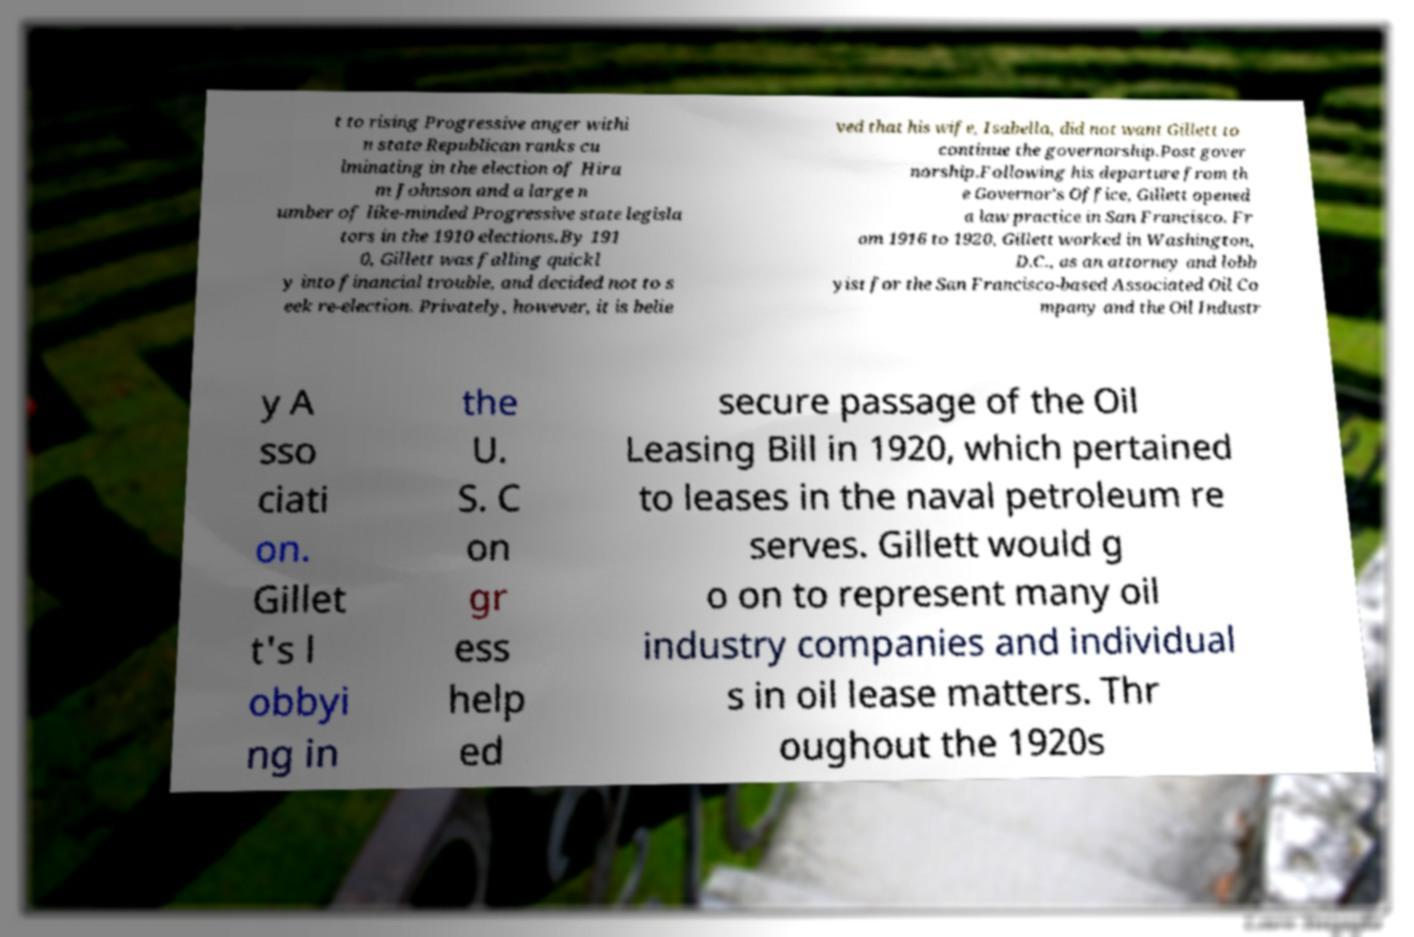There's text embedded in this image that I need extracted. Can you transcribe it verbatim? t to rising Progressive anger withi n state Republican ranks cu lminating in the election of Hira m Johnson and a large n umber of like-minded Progressive state legisla tors in the 1910 elections.By 191 0, Gillett was falling quickl y into financial trouble, and decided not to s eek re-election. Privately, however, it is belie ved that his wife, Isabella, did not want Gillett to continue the governorship.Post gover norship.Following his departure from th e Governor's Office, Gillett opened a law practice in San Francisco. Fr om 1916 to 1920, Gillett worked in Washington, D.C., as an attorney and lobb yist for the San Francisco-based Associated Oil Co mpany and the Oil Industr y A sso ciati on. Gillet t's l obbyi ng in the U. S. C on gr ess help ed secure passage of the Oil Leasing Bill in 1920, which pertained to leases in the naval petroleum re serves. Gillett would g o on to represent many oil industry companies and individual s in oil lease matters. Thr oughout the 1920s 